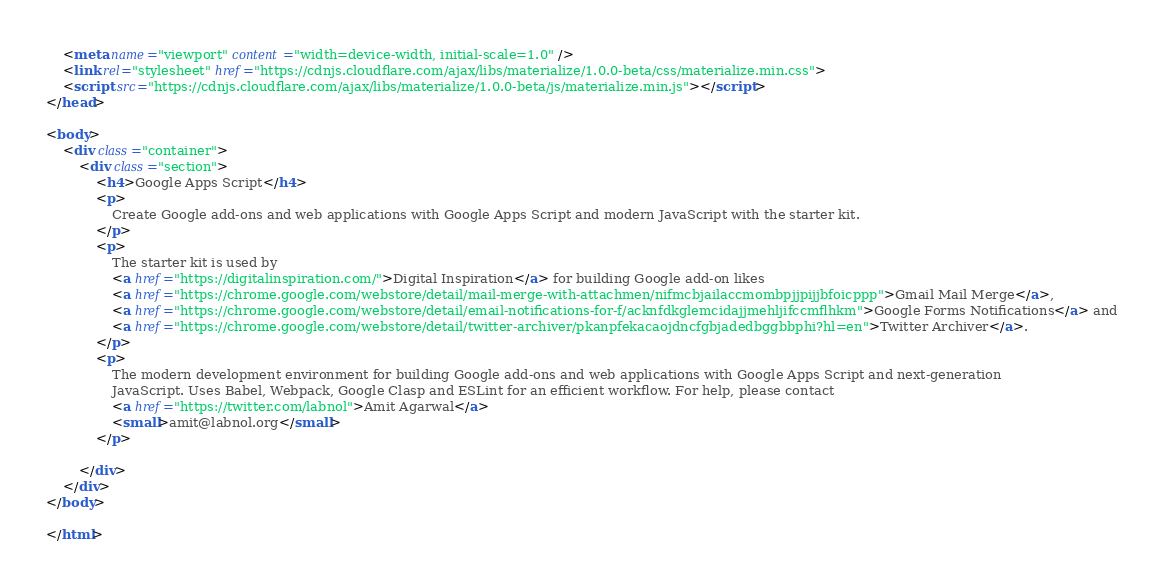<code> <loc_0><loc_0><loc_500><loc_500><_HTML_>    <meta name="viewport" content="width=device-width, initial-scale=1.0" />
    <link rel="stylesheet" href="https://cdnjs.cloudflare.com/ajax/libs/materialize/1.0.0-beta/css/materialize.min.css">
    <script src="https://cdnjs.cloudflare.com/ajax/libs/materialize/1.0.0-beta/js/materialize.min.js"></script>
</head>

<body>
    <div class="container">
        <div class="section">
            <h4>Google Apps Script</h4>
            <p>
                Create Google add-ons and web applications with Google Apps Script and modern JavaScript with the starter kit.
            </p>
            <p>
                The starter kit is used by
                <a href="https://digitalinspiration.com/">Digital Inspiration</a> for building Google add-on likes
                <a href="https://chrome.google.com/webstore/detail/mail-merge-with-attachmen/nifmcbjailaccmombpjjpijjbfoicppp">Gmail Mail Merge</a>,
                <a href="https://chrome.google.com/webstore/detail/email-notifications-for-f/acknfdkglemcidajjmehljifccmflhkm">Google Forms Notifications</a> and
                <a href="https://chrome.google.com/webstore/detail/twitter-archiver/pkanpfekacaojdncfgbjadedbggbbphi?hl=en">Twitter Archiver</a>.
            </p>
            <p>
                The modern development environment for building Google add-ons and web applications with Google Apps Script and next-generation
                JavaScript. Uses Babel, Webpack, Google Clasp and ESLint for an efficient workflow. For help, please contact
                <a href="https://twitter.com/labnol">Amit Agarwal</a>
                <small>amit@labnol.org</small>
            </p>

        </div>
    </div>
</body>

</html></code> 